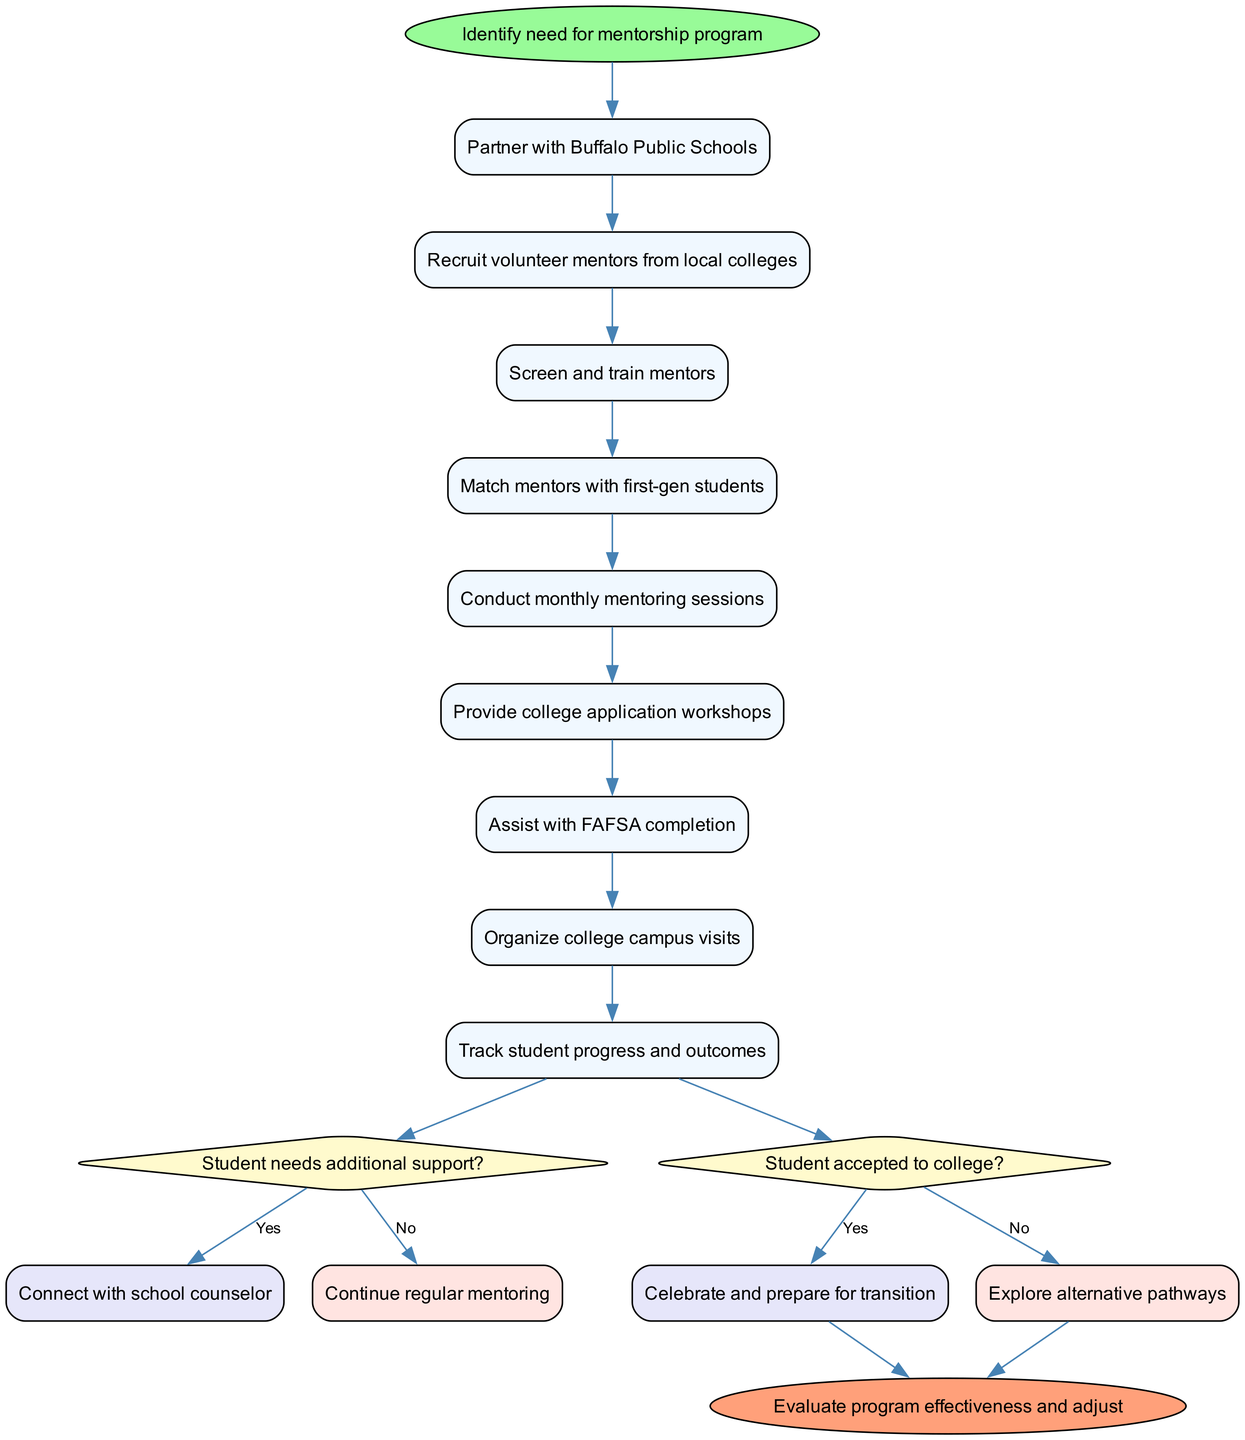What is the starting activity of the mentorship program? The starting point in the diagram indicates the initial activity. It explicitly states "Identify need for mentorship program" as the first action that kicks off the process.
Answer: Identify need for mentorship program How many activities are listed in the diagram? To find the total number of activities, I counted the items in the activities list provided in the data. There are nine distinct activities specified.
Answer: 9 What activity directly follows "Screen and train mentors"? By looking at the flow of the diagram, I can see that "Screen and train mentors" is followed by "Match mentors with first-gen students" as the next step in the sequence.
Answer: Match mentors with first-gen students What happens if a student needs additional support? The diagram branches after the decision about the student's support needs. If the answer is "Yes," it indicates a connection to "Connect with school counselor" as the next action to take.
Answer: Connect with school counselor What are the outcomes if the student is accepted to college? When the diagram reaches the decision about college acceptance, a "Yes" leads to "Celebrate and prepare for transition," indicating a positive outcome. This part of the flow specifies success.
Answer: Celebrate and prepare for transition How many decisions are represented in the diagram? The decisions listed in the diagram specify two distinct decision points regarding additional support needs and college acceptance, which I counted to answer the question about the number of decision nodes.
Answer: 2 What is the final step in the mentorship program? The end node in the diagram clearly states the final action, which is evaluating the program effectiveness and making adjustments based on that evaluation.
Answer: Evaluate program effectiveness and adjust If the student is not accepted to college, what is the next step? The diagram flows from the college acceptance decision. If the answer is "No," it leads to the action to "Explore alternative pathways," indicating what to do when acceptance does not occur.
Answer: Explore alternative pathways 